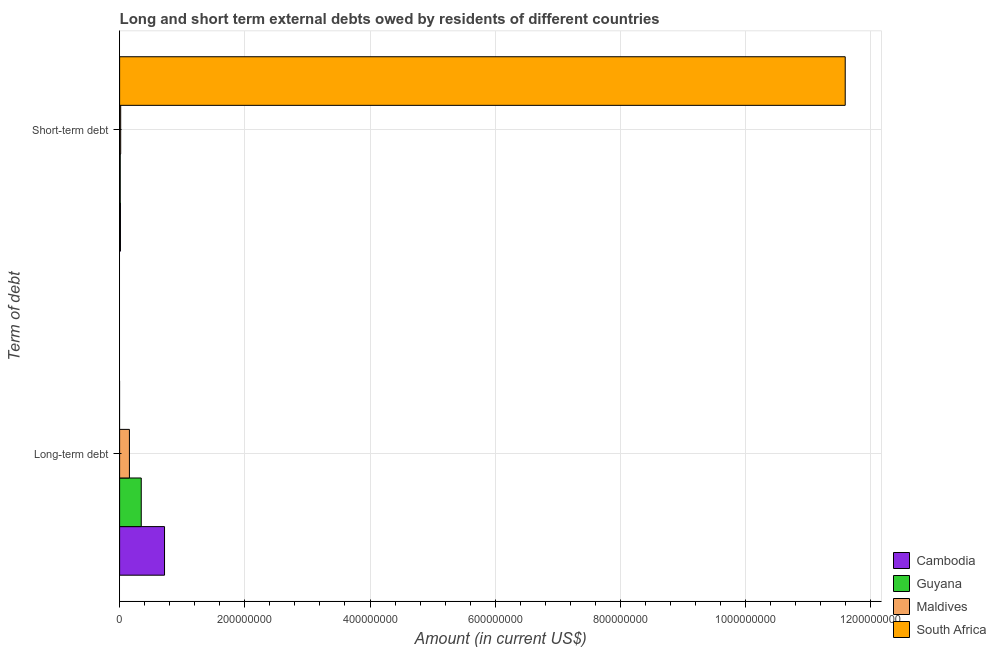How many groups of bars are there?
Make the answer very short. 2. Are the number of bars on each tick of the Y-axis equal?
Offer a terse response. No. How many bars are there on the 2nd tick from the top?
Make the answer very short. 3. What is the label of the 2nd group of bars from the top?
Offer a very short reply. Long-term debt. What is the short-term debts owed by residents in Maldives?
Ensure brevity in your answer.  1.72e+06. Across all countries, what is the maximum long-term debts owed by residents?
Your response must be concise. 7.18e+07. Across all countries, what is the minimum short-term debts owed by residents?
Offer a terse response. 1.01e+06. In which country was the long-term debts owed by residents maximum?
Provide a succinct answer. Cambodia. What is the total short-term debts owed by residents in the graph?
Provide a short and direct response. 1.16e+09. What is the difference between the long-term debts owed by residents in Cambodia and that in Guyana?
Your answer should be compact. 3.72e+07. What is the difference between the short-term debts owed by residents in Maldives and the long-term debts owed by residents in South Africa?
Your answer should be very brief. 1.72e+06. What is the average long-term debts owed by residents per country?
Your response must be concise. 3.05e+07. What is the difference between the short-term debts owed by residents and long-term debts owed by residents in Guyana?
Your answer should be very brief. -3.36e+07. In how many countries, is the long-term debts owed by residents greater than 1120000000 US$?
Your answer should be compact. 0. What is the ratio of the short-term debts owed by residents in South Africa to that in Guyana?
Your answer should be very brief. 1147.52. Is the short-term debts owed by residents in Guyana less than that in Maldives?
Make the answer very short. Yes. In how many countries, is the long-term debts owed by residents greater than the average long-term debts owed by residents taken over all countries?
Your answer should be compact. 2. How many bars are there?
Your answer should be compact. 7. How many countries are there in the graph?
Your response must be concise. 4. What is the difference between two consecutive major ticks on the X-axis?
Give a very brief answer. 2.00e+08. Does the graph contain grids?
Give a very brief answer. Yes. Where does the legend appear in the graph?
Your answer should be very brief. Bottom right. How many legend labels are there?
Provide a short and direct response. 4. What is the title of the graph?
Your answer should be very brief. Long and short term external debts owed by residents of different countries. Does "Croatia" appear as one of the legend labels in the graph?
Your answer should be very brief. No. What is the label or title of the X-axis?
Give a very brief answer. Amount (in current US$). What is the label or title of the Y-axis?
Offer a terse response. Term of debt. What is the Amount (in current US$) in Cambodia in Long-term debt?
Your response must be concise. 7.18e+07. What is the Amount (in current US$) in Guyana in Long-term debt?
Ensure brevity in your answer.  3.46e+07. What is the Amount (in current US$) in Maldives in Long-term debt?
Your answer should be very brief. 1.57e+07. What is the Amount (in current US$) of South Africa in Long-term debt?
Provide a short and direct response. 0. What is the Amount (in current US$) of Cambodia in Short-term debt?
Your answer should be compact. 1.34e+06. What is the Amount (in current US$) in Guyana in Short-term debt?
Offer a very short reply. 1.01e+06. What is the Amount (in current US$) in Maldives in Short-term debt?
Give a very brief answer. 1.72e+06. What is the Amount (in current US$) of South Africa in Short-term debt?
Ensure brevity in your answer.  1.16e+09. Across all Term of debt, what is the maximum Amount (in current US$) in Cambodia?
Ensure brevity in your answer.  7.18e+07. Across all Term of debt, what is the maximum Amount (in current US$) in Guyana?
Offer a terse response. 3.46e+07. Across all Term of debt, what is the maximum Amount (in current US$) of Maldives?
Offer a very short reply. 1.57e+07. Across all Term of debt, what is the maximum Amount (in current US$) in South Africa?
Give a very brief answer. 1.16e+09. Across all Term of debt, what is the minimum Amount (in current US$) in Cambodia?
Your answer should be compact. 1.34e+06. Across all Term of debt, what is the minimum Amount (in current US$) of Guyana?
Make the answer very short. 1.01e+06. Across all Term of debt, what is the minimum Amount (in current US$) of Maldives?
Give a very brief answer. 1.72e+06. Across all Term of debt, what is the minimum Amount (in current US$) of South Africa?
Give a very brief answer. 0. What is the total Amount (in current US$) of Cambodia in the graph?
Your answer should be very brief. 7.31e+07. What is the total Amount (in current US$) in Guyana in the graph?
Provide a succinct answer. 3.56e+07. What is the total Amount (in current US$) in Maldives in the graph?
Offer a terse response. 1.74e+07. What is the total Amount (in current US$) in South Africa in the graph?
Your answer should be compact. 1.16e+09. What is the difference between the Amount (in current US$) in Cambodia in Long-term debt and that in Short-term debt?
Offer a terse response. 7.04e+07. What is the difference between the Amount (in current US$) in Guyana in Long-term debt and that in Short-term debt?
Ensure brevity in your answer.  3.36e+07. What is the difference between the Amount (in current US$) in Maldives in Long-term debt and that in Short-term debt?
Your answer should be compact. 1.39e+07. What is the difference between the Amount (in current US$) in Cambodia in Long-term debt and the Amount (in current US$) in Guyana in Short-term debt?
Make the answer very short. 7.07e+07. What is the difference between the Amount (in current US$) of Cambodia in Long-term debt and the Amount (in current US$) of Maldives in Short-term debt?
Give a very brief answer. 7.00e+07. What is the difference between the Amount (in current US$) of Cambodia in Long-term debt and the Amount (in current US$) of South Africa in Short-term debt?
Give a very brief answer. -1.09e+09. What is the difference between the Amount (in current US$) of Guyana in Long-term debt and the Amount (in current US$) of Maldives in Short-term debt?
Keep it short and to the point. 3.28e+07. What is the difference between the Amount (in current US$) in Guyana in Long-term debt and the Amount (in current US$) in South Africa in Short-term debt?
Offer a very short reply. -1.12e+09. What is the difference between the Amount (in current US$) in Maldives in Long-term debt and the Amount (in current US$) in South Africa in Short-term debt?
Provide a succinct answer. -1.14e+09. What is the average Amount (in current US$) of Cambodia per Term of debt?
Provide a short and direct response. 3.65e+07. What is the average Amount (in current US$) in Guyana per Term of debt?
Offer a terse response. 1.78e+07. What is the average Amount (in current US$) of Maldives per Term of debt?
Ensure brevity in your answer.  8.69e+06. What is the average Amount (in current US$) in South Africa per Term of debt?
Your response must be concise. 5.80e+08. What is the difference between the Amount (in current US$) of Cambodia and Amount (in current US$) of Guyana in Long-term debt?
Provide a short and direct response. 3.72e+07. What is the difference between the Amount (in current US$) in Cambodia and Amount (in current US$) in Maldives in Long-term debt?
Give a very brief answer. 5.61e+07. What is the difference between the Amount (in current US$) in Guyana and Amount (in current US$) in Maldives in Long-term debt?
Your answer should be very brief. 1.89e+07. What is the difference between the Amount (in current US$) in Cambodia and Amount (in current US$) in Maldives in Short-term debt?
Your response must be concise. -3.80e+05. What is the difference between the Amount (in current US$) of Cambodia and Amount (in current US$) of South Africa in Short-term debt?
Ensure brevity in your answer.  -1.16e+09. What is the difference between the Amount (in current US$) of Guyana and Amount (in current US$) of Maldives in Short-term debt?
Ensure brevity in your answer.  -7.10e+05. What is the difference between the Amount (in current US$) in Guyana and Amount (in current US$) in South Africa in Short-term debt?
Ensure brevity in your answer.  -1.16e+09. What is the difference between the Amount (in current US$) in Maldives and Amount (in current US$) in South Africa in Short-term debt?
Ensure brevity in your answer.  -1.16e+09. What is the ratio of the Amount (in current US$) of Cambodia in Long-term debt to that in Short-term debt?
Your response must be concise. 53.55. What is the ratio of the Amount (in current US$) of Guyana in Long-term debt to that in Short-term debt?
Provide a short and direct response. 34.22. What is the ratio of the Amount (in current US$) of Maldives in Long-term debt to that in Short-term debt?
Provide a succinct answer. 9.11. What is the difference between the highest and the second highest Amount (in current US$) of Cambodia?
Offer a terse response. 7.04e+07. What is the difference between the highest and the second highest Amount (in current US$) in Guyana?
Your answer should be compact. 3.36e+07. What is the difference between the highest and the second highest Amount (in current US$) in Maldives?
Your answer should be very brief. 1.39e+07. What is the difference between the highest and the lowest Amount (in current US$) in Cambodia?
Provide a succinct answer. 7.04e+07. What is the difference between the highest and the lowest Amount (in current US$) in Guyana?
Make the answer very short. 3.36e+07. What is the difference between the highest and the lowest Amount (in current US$) of Maldives?
Make the answer very short. 1.39e+07. What is the difference between the highest and the lowest Amount (in current US$) of South Africa?
Ensure brevity in your answer.  1.16e+09. 